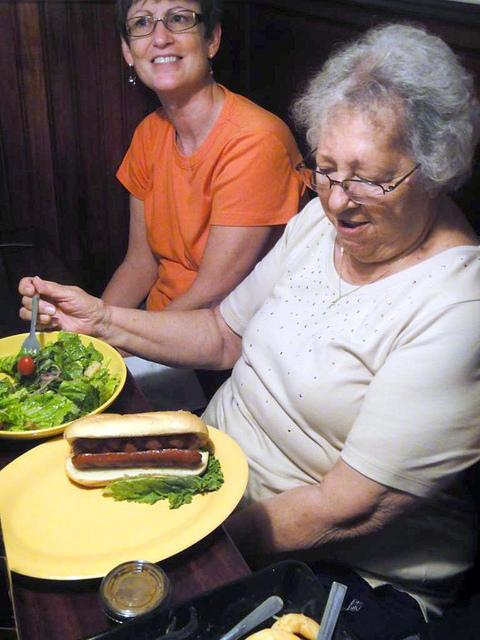What is the woman sitting on?
Keep it brief. Chair. What plate is the salad on?
Quick response, please. Yellow one. What is the table made out of?
Short answer required. Wood. Is the older woman looking forward to eating the hotdog?
Concise answer only. Yes. 